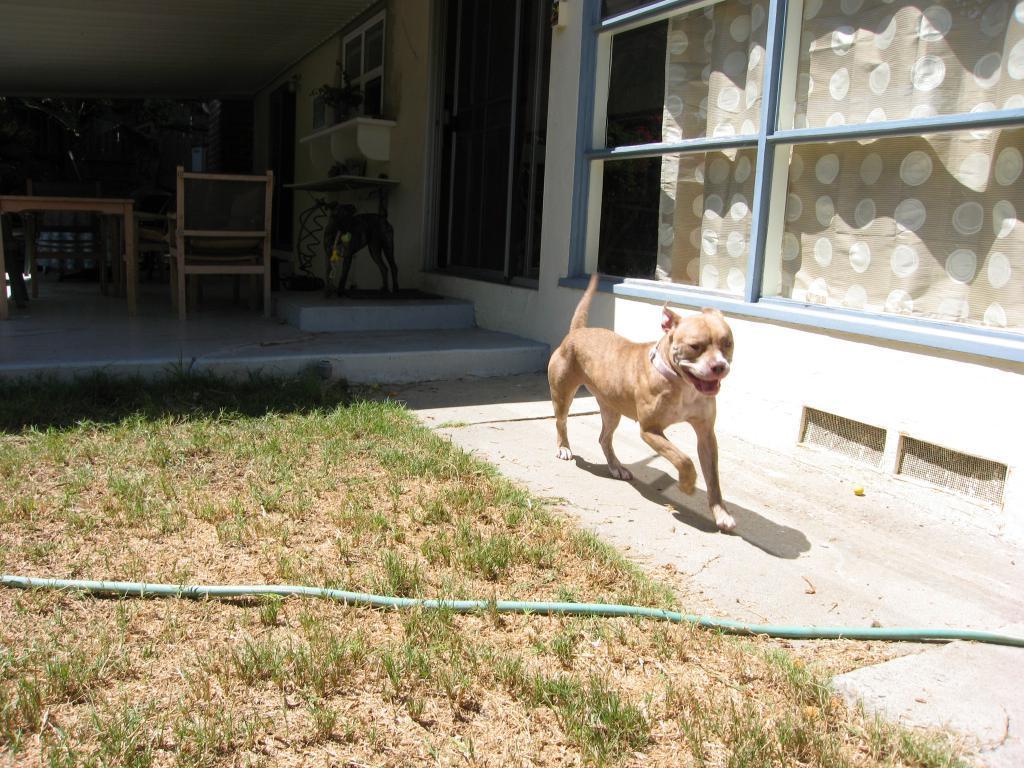Can you describe this image briefly? a dog is running on the right. there is a pipe in front of him. at the right , there are window and curtains. behind the dog there are table and chairs. 